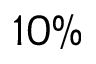<formula> <loc_0><loc_0><loc_500><loc_500>1 0 \%</formula> 